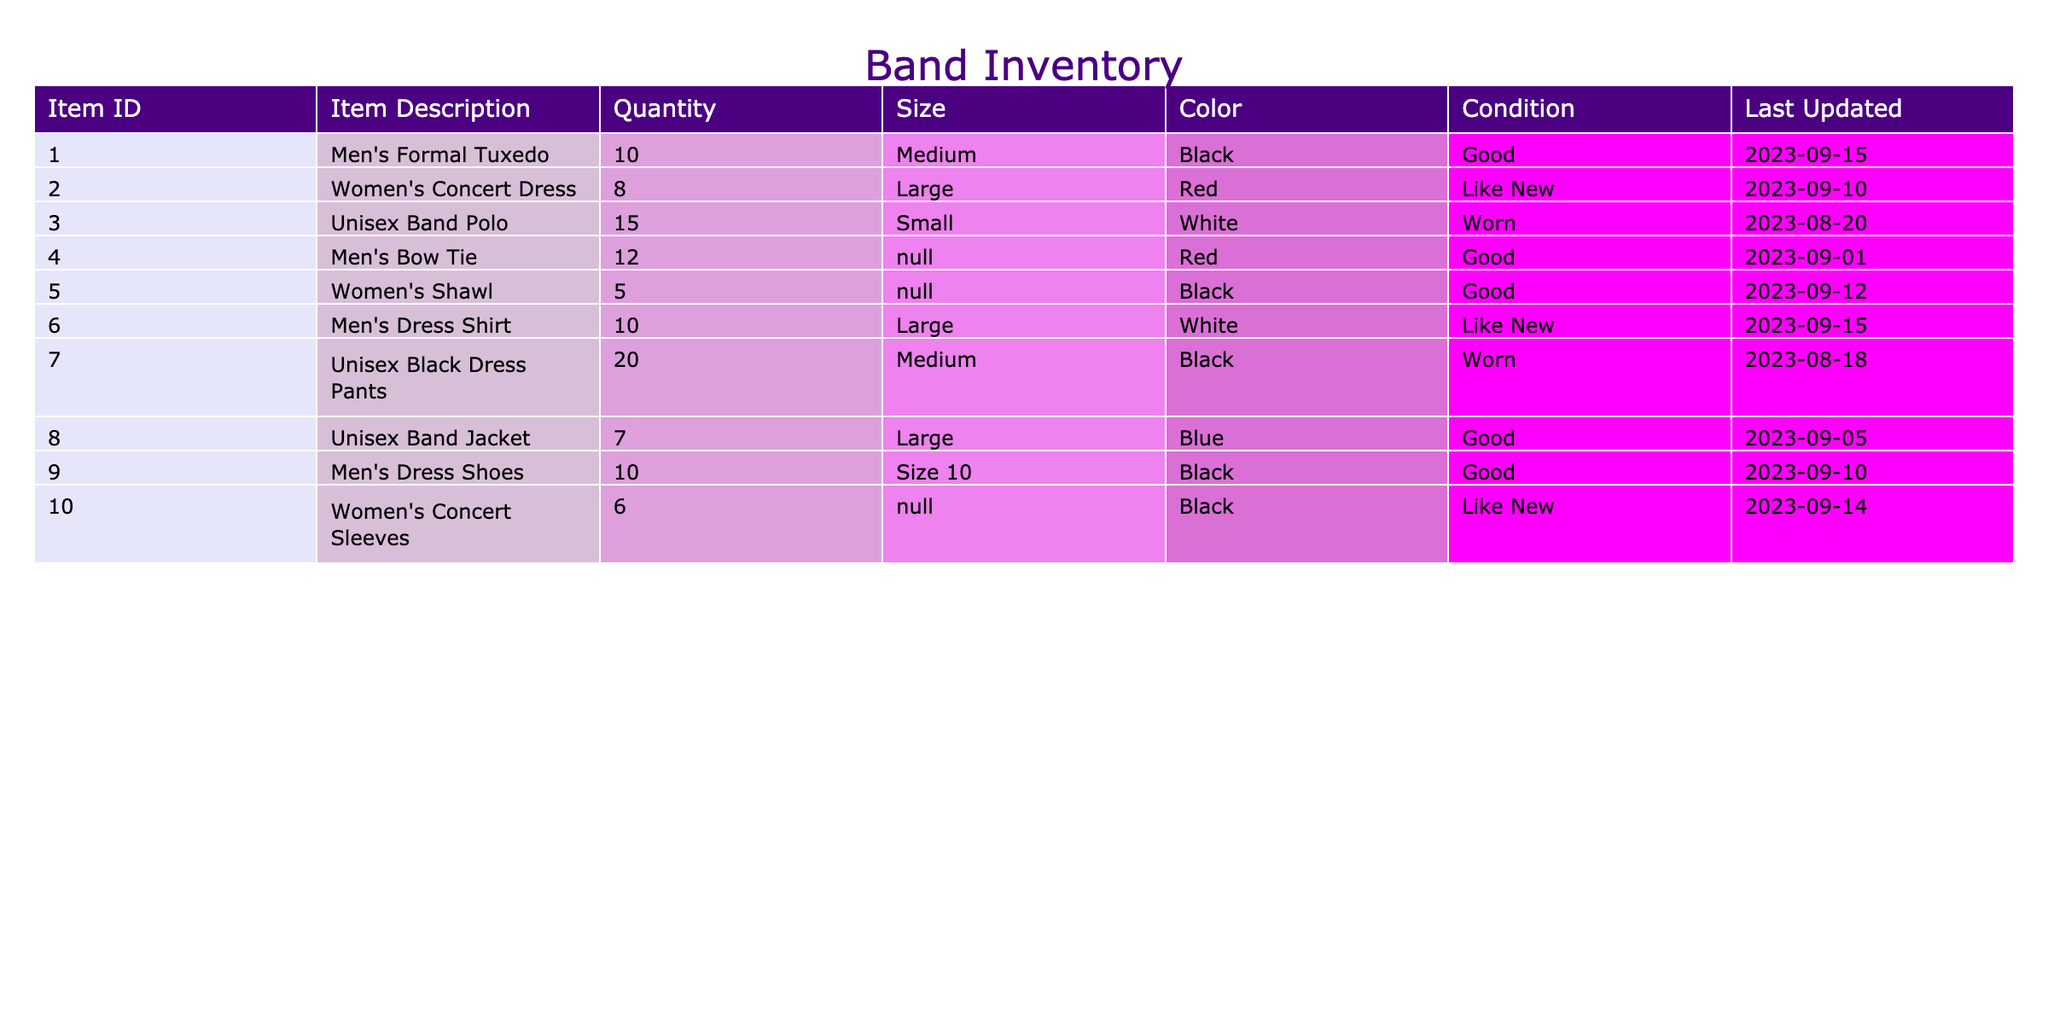What is the total number of Women's Concert Dresses available? The table shows that there are 8 Women's Concert Dresses listed under the Quantity column, so adding that gives a total of 8.
Answer: 8 How many items in the inventory are in 'Like New' condition? The table lists three items with the condition 'Like New': Women's Concert Dress, Men's Dress Shirt, and Women's Concert Sleeves. Therefore, there are 3 items in 'Like New' condition.
Answer: 3 What is the average quantity of Unisex Band Polo and Unisex Black Dress Pants? The quantities for Unisex Band Polo and Unisex Black Dress Pants are 15 and 20 respectively. To find the average: (15 + 20) / 2 = 17.5.
Answer: 17.5 Is there a Men's Tuxedo available in Large size? The table lists 10 Men's Formal Tuxedos, but they are all in Medium size. Therefore, there are no Men's Tuxedos available in Large size.
Answer: No What is the total quantity of items that are currently in 'Worn' condition? There are two items in 'Worn' condition: Unisex Band Polo (15) and Unisex Black Dress Pants (20). Adding these gives: 15 + 20 = 35.
Answer: 35 How many more Men's Dress Shoes are available than Women's Shawls? There are 10 Men's Dress Shoes and 5 Women's Shawls. To find the difference: 10 - 5 = 5, which indicates there are 5 more Men's Dress Shoes.
Answer: 5 What color is the most numerous item in the inventory? The item with the highest quantity is Unisex Black Dress Pants (20), which are in Black color. Therefore, the most numerous item color is Black.
Answer: Black Are there any items in the inventory that are both 'Good' condition and Black color? The Men's Formal Tuxedo and Men's Bow Tie are listed in good condition. Out of these, the Men's Formal Tuxedo is Black, confirming that at least one item meets both conditions.
Answer: Yes What is the total quantity of concert attire for both men and women combined? Adding the total quantities for men and women together: Men's Formal Tuxedo (10) + Men's Bow Tie (12) + Men's Dress Shirt (10) + Men's Dress Shoes (10) + Women's Concert Dress (8) + Women's Shawl (5) + Women's Concert Sleeves (6), this sums to 10 + 12 + 10 + 10 + 8 + 5 + 6 = 61.
Answer: 61 